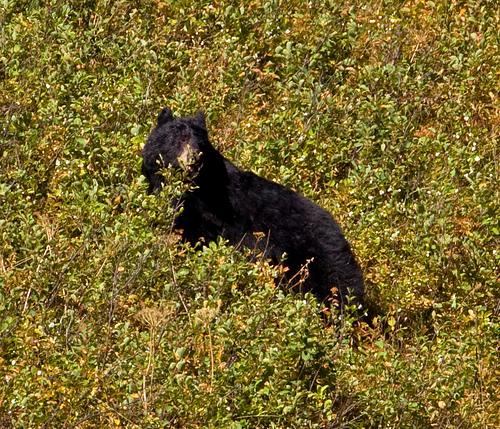Indicate the primary subject in the image and explain its current endeavor. The picture features a black bear with a brown spot on its snout, as it scouts through a lush green environment filled with branches and shadows. Please mention the central object of the image and what action it is performing. A black bear is foraging among trees and plants with its brownish snout and ears standing up. Express the main element of the photograph and the task it is participating in. A considerable black bear is seen delving in a field filled with green and dry leaves and multiple tree branches. Could you give a brief description of the main creature in the image and its activity? A black furry animal, possibly a bear, is searching for food in a busy terrain area with green leafy plants and dry leaves. Narrate a summary of the prominent figure in the photograph and its ongoing action. An enormous black bear is rummaging through an overgrowth of green and yellow plants in a field. In a few words, can you tell me what the main subject is in the image, and what it is currently doing? The image displays a black bear with brownish muzzle exploring a green leafy brush area with several trees. Can you describe the main animal in the picture and what it's doing? A large black bear is sitting among several plants and branches, with its black eyes and white nose visible. Briefly share what the focal point of the image is and the action it is engaged in. The image shows a black bear with a white nose and brown snout, investigating its surroundings among trees and plants. Write a concise description of the primary character in the image and its present activity. A black bear with black eyes and furry ears is foraging among leaves and branches in a wooded area. Outline the central figure of the image and the action it is undertaking. A black furry animal, probably a bear, is intense on exploring a terrain filled with green leafy plants and several branches. 